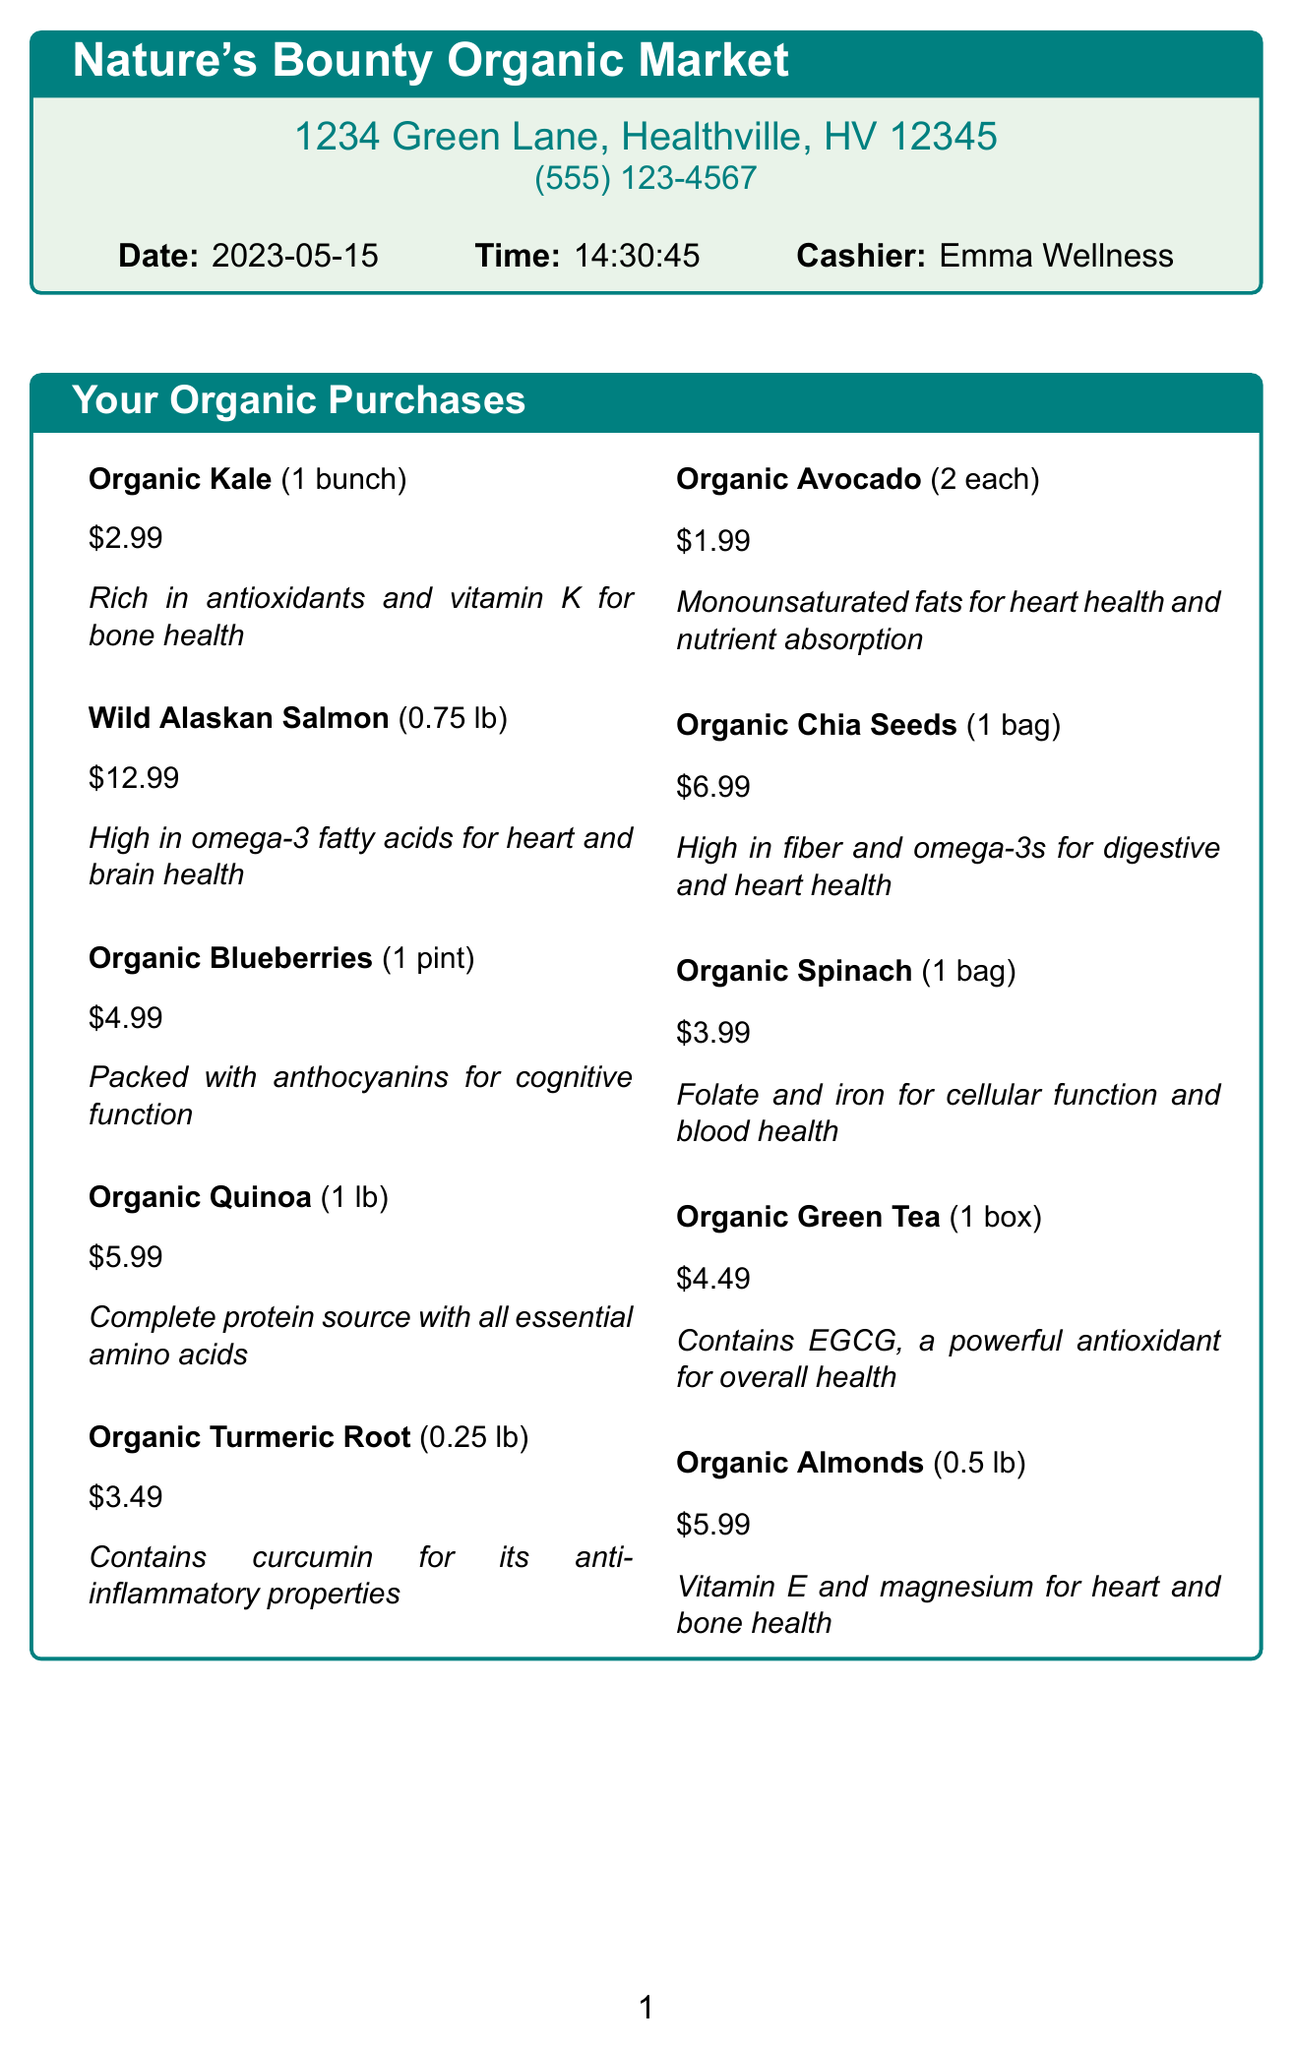What is the store name? The store name is mentioned prominently at the top of the receipt.
Answer: Nature's Bounty Organic Market What is the total amount spent? The total amount spent is the final amount indicated before any footer messages.
Answer: $57.13 Who was the cashier? The cashier's name is listed near the date and time of the transaction.
Answer: Emma Wellness What is the health benefit of Organic Kale? The health benefit is provided in a description following the item on the receipt.
Answer: Rich in antioxidants and vitamin K for bone health How much does Organic Blueberries cost? The price for the Organic Blueberries is specifically mentioned next to the item.
Answer: $4.99 What items contribute to heart health in this receipt? This requires considering multiple items and their health benefits listed on the receipt.
Answer: Wild Alaskan Salmon, Organic Avocado, Organic Chia Seeds, Organic Almonds What is the quantity of Organic Chia Seeds purchased? The quantity is noted next to the item name on the receipt.
Answer: 1 bag What is the subtotal before tax? The subtotal is provided in a dedicated section of the receipt.
Answer: $53.90 What nutritional tip is provided? The nutritional tip is outlined in its own section at the bottom of the document.
Answer: Combining these nutrient-dense foods can help optimize your body's absorption of vitamins and minerals 